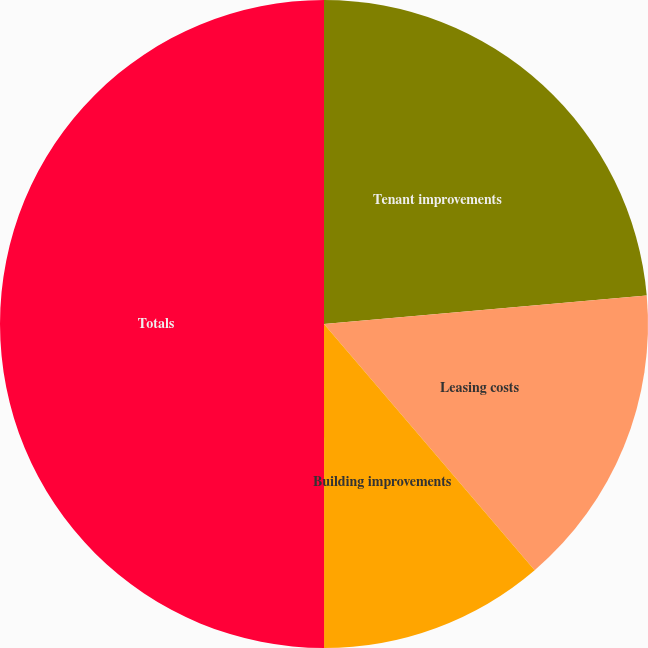Convert chart. <chart><loc_0><loc_0><loc_500><loc_500><pie_chart><fcel>Tenant improvements<fcel>Leasing costs<fcel>Building improvements<fcel>Totals<nl><fcel>23.59%<fcel>15.14%<fcel>11.26%<fcel>50.0%<nl></chart> 